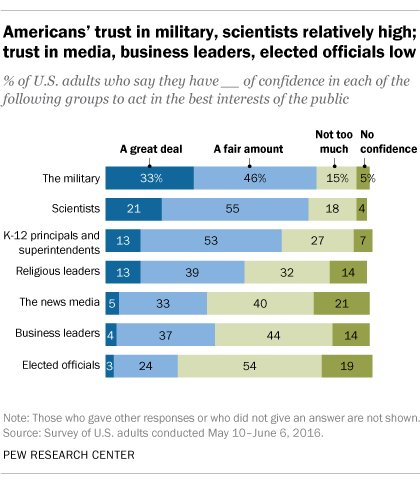Highlight a few significant elements in this photo. The average value of the last three bars is 31.33. The dark blue bar represents a significant amount. 